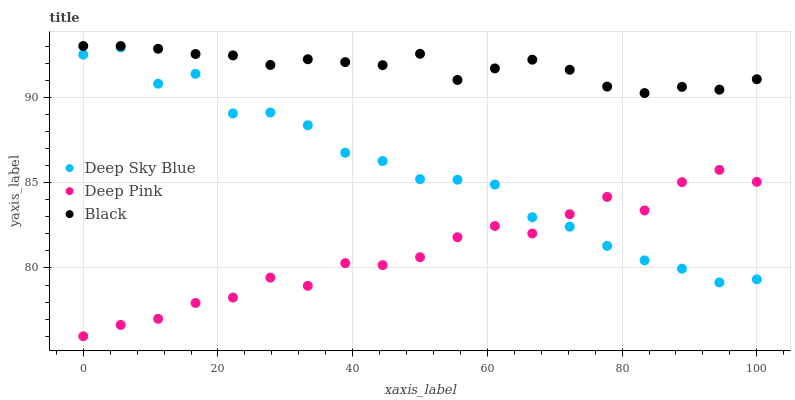Does Deep Pink have the minimum area under the curve?
Answer yes or no. Yes. Does Black have the maximum area under the curve?
Answer yes or no. Yes. Does Deep Sky Blue have the minimum area under the curve?
Answer yes or no. No. Does Deep Sky Blue have the maximum area under the curve?
Answer yes or no. No. Is Black the smoothest?
Answer yes or no. Yes. Is Deep Sky Blue the roughest?
Answer yes or no. Yes. Is Deep Sky Blue the smoothest?
Answer yes or no. No. Is Black the roughest?
Answer yes or no. No. Does Deep Pink have the lowest value?
Answer yes or no. Yes. Does Deep Sky Blue have the lowest value?
Answer yes or no. No. Does Black have the highest value?
Answer yes or no. Yes. Does Deep Sky Blue have the highest value?
Answer yes or no. No. Is Deep Pink less than Black?
Answer yes or no. Yes. Is Black greater than Deep Pink?
Answer yes or no. Yes. Does Deep Pink intersect Deep Sky Blue?
Answer yes or no. Yes. Is Deep Pink less than Deep Sky Blue?
Answer yes or no. No. Is Deep Pink greater than Deep Sky Blue?
Answer yes or no. No. Does Deep Pink intersect Black?
Answer yes or no. No. 